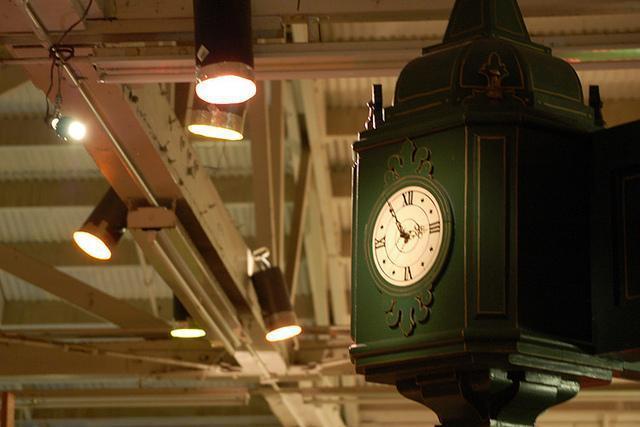How many lights are turned on in the photo?
Give a very brief answer. 6. 